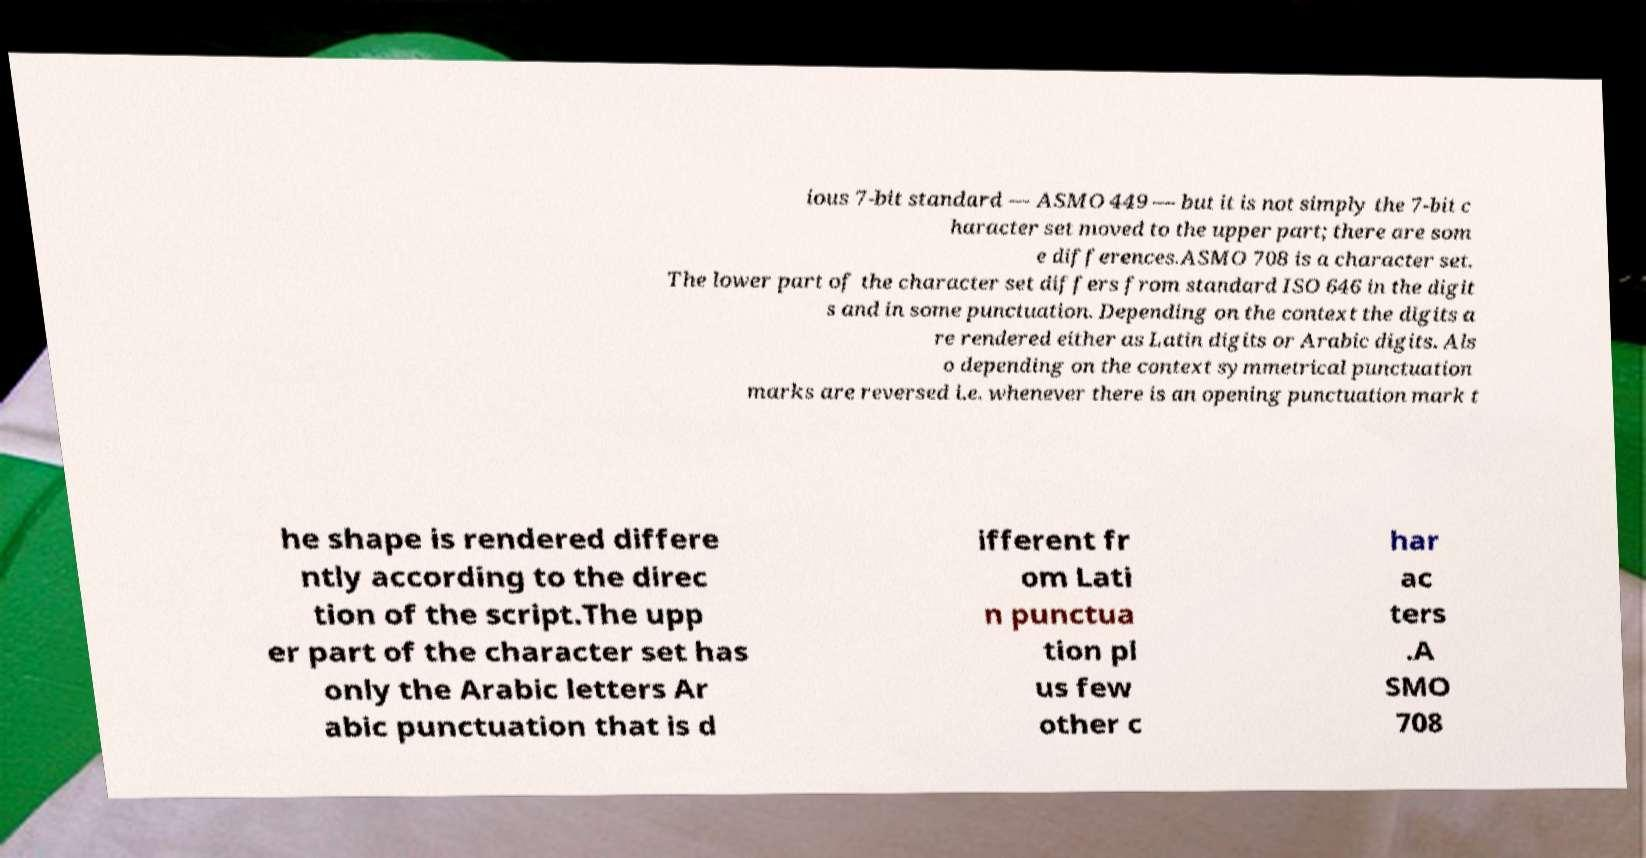I need the written content from this picture converted into text. Can you do that? ious 7-bit standard — ASMO 449 — but it is not simply the 7-bit c haracter set moved to the upper part; there are som e differences.ASMO 708 is a character set. The lower part of the character set differs from standard ISO 646 in the digit s and in some punctuation. Depending on the context the digits a re rendered either as Latin digits or Arabic digits. Als o depending on the context symmetrical punctuation marks are reversed i.e. whenever there is an opening punctuation mark t he shape is rendered differe ntly according to the direc tion of the script.The upp er part of the character set has only the Arabic letters Ar abic punctuation that is d ifferent fr om Lati n punctua tion pl us few other c har ac ters .A SMO 708 